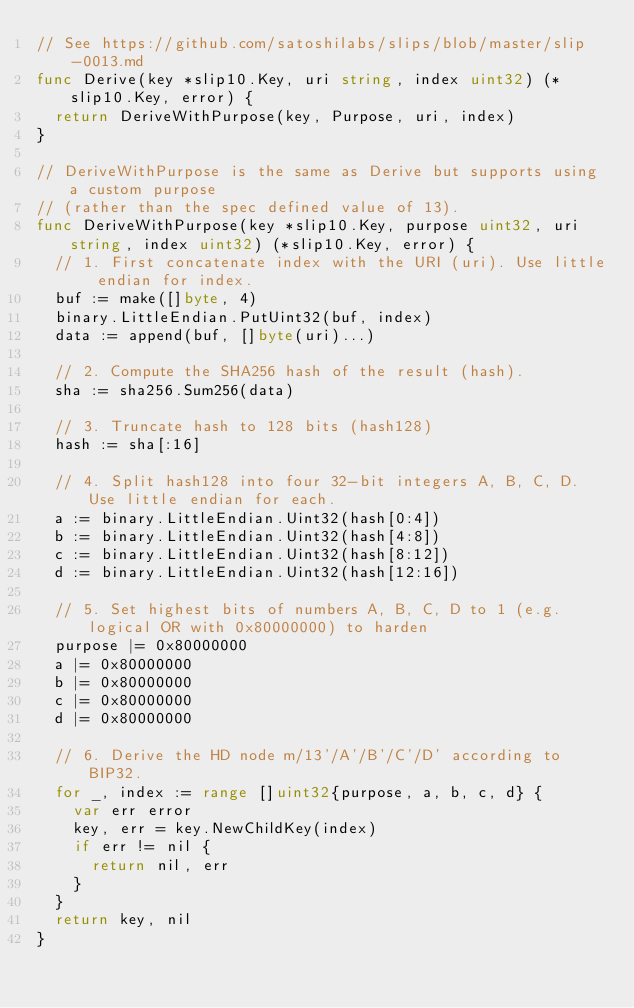Convert code to text. <code><loc_0><loc_0><loc_500><loc_500><_Go_>// See https://github.com/satoshilabs/slips/blob/master/slip-0013.md
func Derive(key *slip10.Key, uri string, index uint32) (*slip10.Key, error) {
	return DeriveWithPurpose(key, Purpose, uri, index)
}

// DeriveWithPurpose is the same as Derive but supports using a custom purpose
// (rather than the spec defined value of 13).
func DeriveWithPurpose(key *slip10.Key, purpose uint32, uri string, index uint32) (*slip10.Key, error) {
	// 1. First concatenate index with the URI (uri). Use little endian for index.
	buf := make([]byte, 4)
	binary.LittleEndian.PutUint32(buf, index)
	data := append(buf, []byte(uri)...)

	// 2. Compute the SHA256 hash of the result (hash).
	sha := sha256.Sum256(data)

	// 3. Truncate hash to 128 bits (hash128)
	hash := sha[:16]

	// 4. Split hash128 into four 32-bit integers A, B, C, D. Use little endian for each.
	a := binary.LittleEndian.Uint32(hash[0:4])
	b := binary.LittleEndian.Uint32(hash[4:8])
	c := binary.LittleEndian.Uint32(hash[8:12])
	d := binary.LittleEndian.Uint32(hash[12:16])

	// 5. Set highest bits of numbers A, B, C, D to 1 (e.g. logical OR with 0x80000000) to harden
	purpose |= 0x80000000
	a |= 0x80000000
	b |= 0x80000000
	c |= 0x80000000
	d |= 0x80000000

	// 6. Derive the HD node m/13'/A'/B'/C'/D' according to BIP32.
	for _, index := range []uint32{purpose, a, b, c, d} {
		var err error
		key, err = key.NewChildKey(index)
		if err != nil {
			return nil, err
		}
	}
	return key, nil
}
</code> 